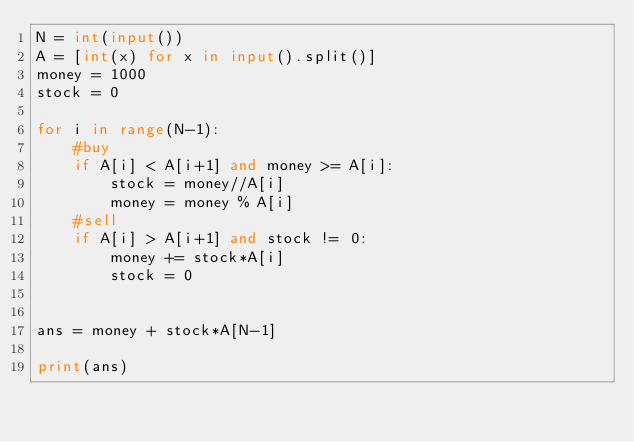Convert code to text. <code><loc_0><loc_0><loc_500><loc_500><_Python_>N = int(input())
A = [int(x) for x in input().split()]
money = 1000
stock = 0

for i in range(N-1):
    #buy
    if A[i] < A[i+1] and money >= A[i]:
        stock = money//A[i]
        money = money % A[i]
    #sell
    if A[i] > A[i+1] and stock != 0:
        money += stock*A[i]
        stock = 0
        

ans = money + stock*A[N-1]       

print(ans) </code> 